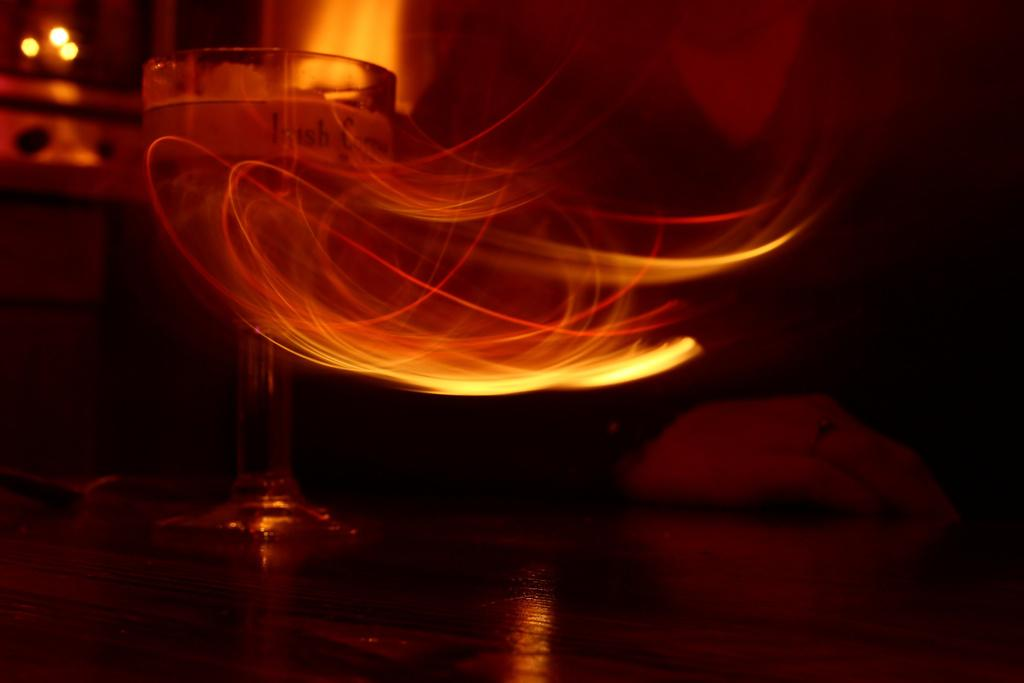What can be seen in the image that provides illumination? There are lights in the image. What object is located on the left side of the image? There is a glass on the left side of the image. How many goldfish are swimming in the glass on the left side of the image? There are no goldfish present in the image; it only features a glass. Can you see any bikes or windows in the image? There is no mention of bikes or windows in the image; it only contains lights and a glass. 